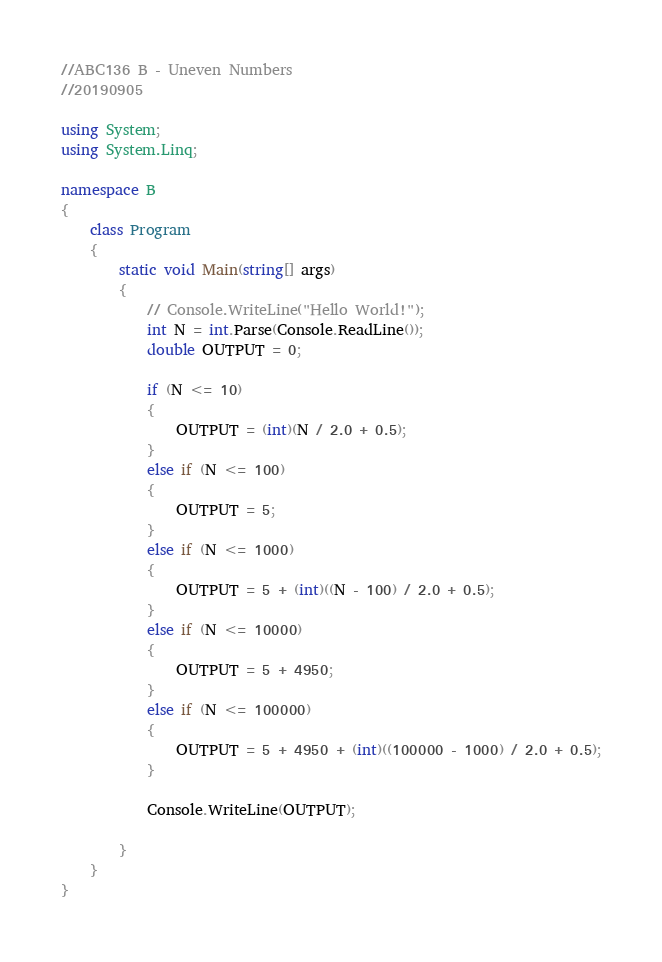Convert code to text. <code><loc_0><loc_0><loc_500><loc_500><_C#_>//ABC136 B - Uneven Numbers
//20190905

using System;
using System.Linq;

namespace B
{
    class Program
    {
        static void Main(string[] args)
        {
            // Console.WriteLine("Hello World!");
            int N = int.Parse(Console.ReadLine());
            double OUTPUT = 0;

            if (N <= 10)
            {
                OUTPUT = (int)(N / 2.0 + 0.5);
            }
            else if (N <= 100)
            {
                OUTPUT = 5;
            }
            else if (N <= 1000)
            {
                OUTPUT = 5 + (int)((N - 100) / 2.0 + 0.5);
            }
            else if (N <= 10000)
            {
                OUTPUT = 5 + 4950;
            }
            else if (N <= 100000)
            {
                OUTPUT = 5 + 4950 + (int)((100000 - 1000) / 2.0 + 0.5);
            }

            Console.WriteLine(OUTPUT);

        }
    }
}
</code> 